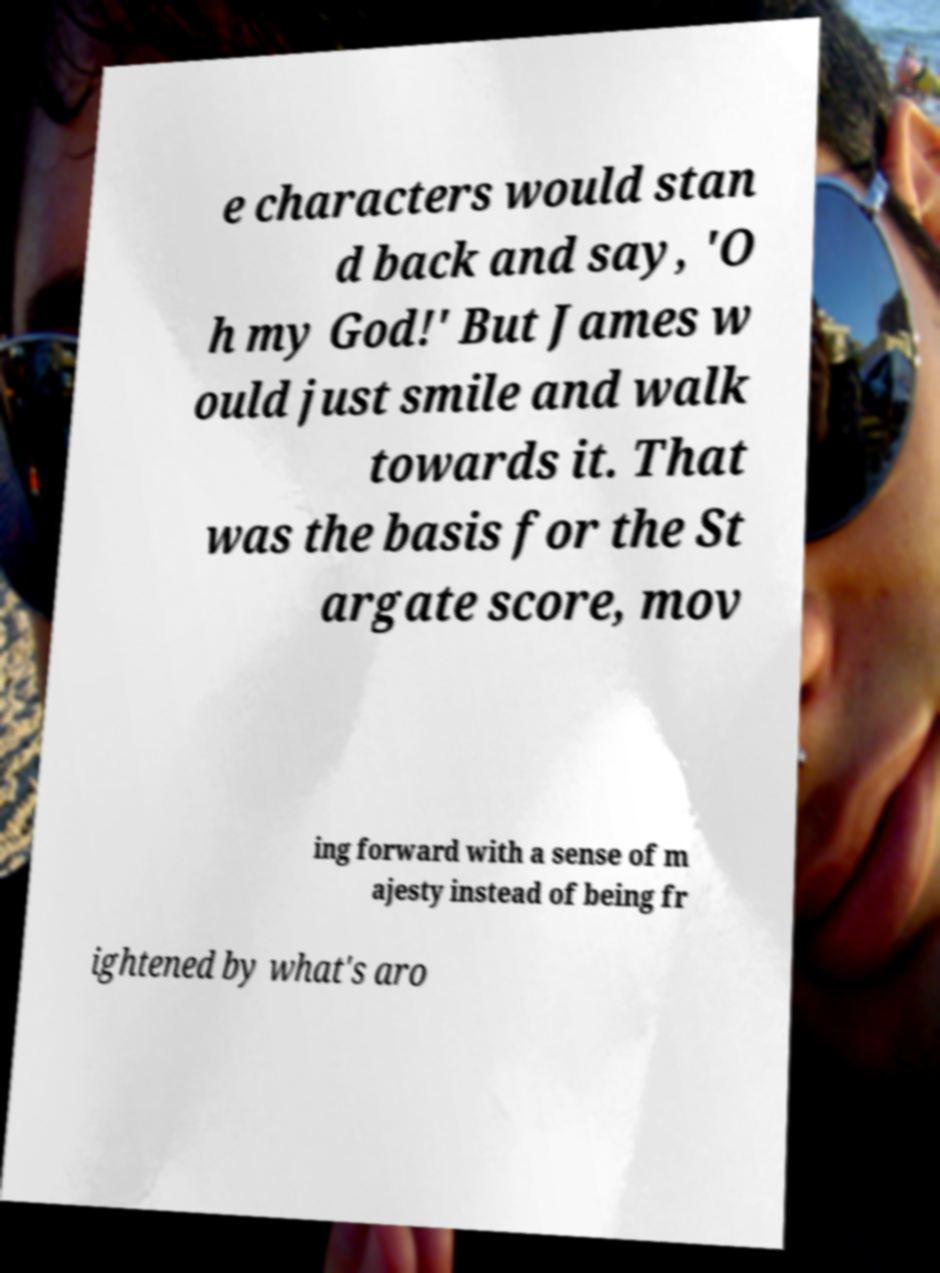For documentation purposes, I need the text within this image transcribed. Could you provide that? e characters would stan d back and say, 'O h my God!' But James w ould just smile and walk towards it. That was the basis for the St argate score, mov ing forward with a sense of m ajesty instead of being fr ightened by what's aro 